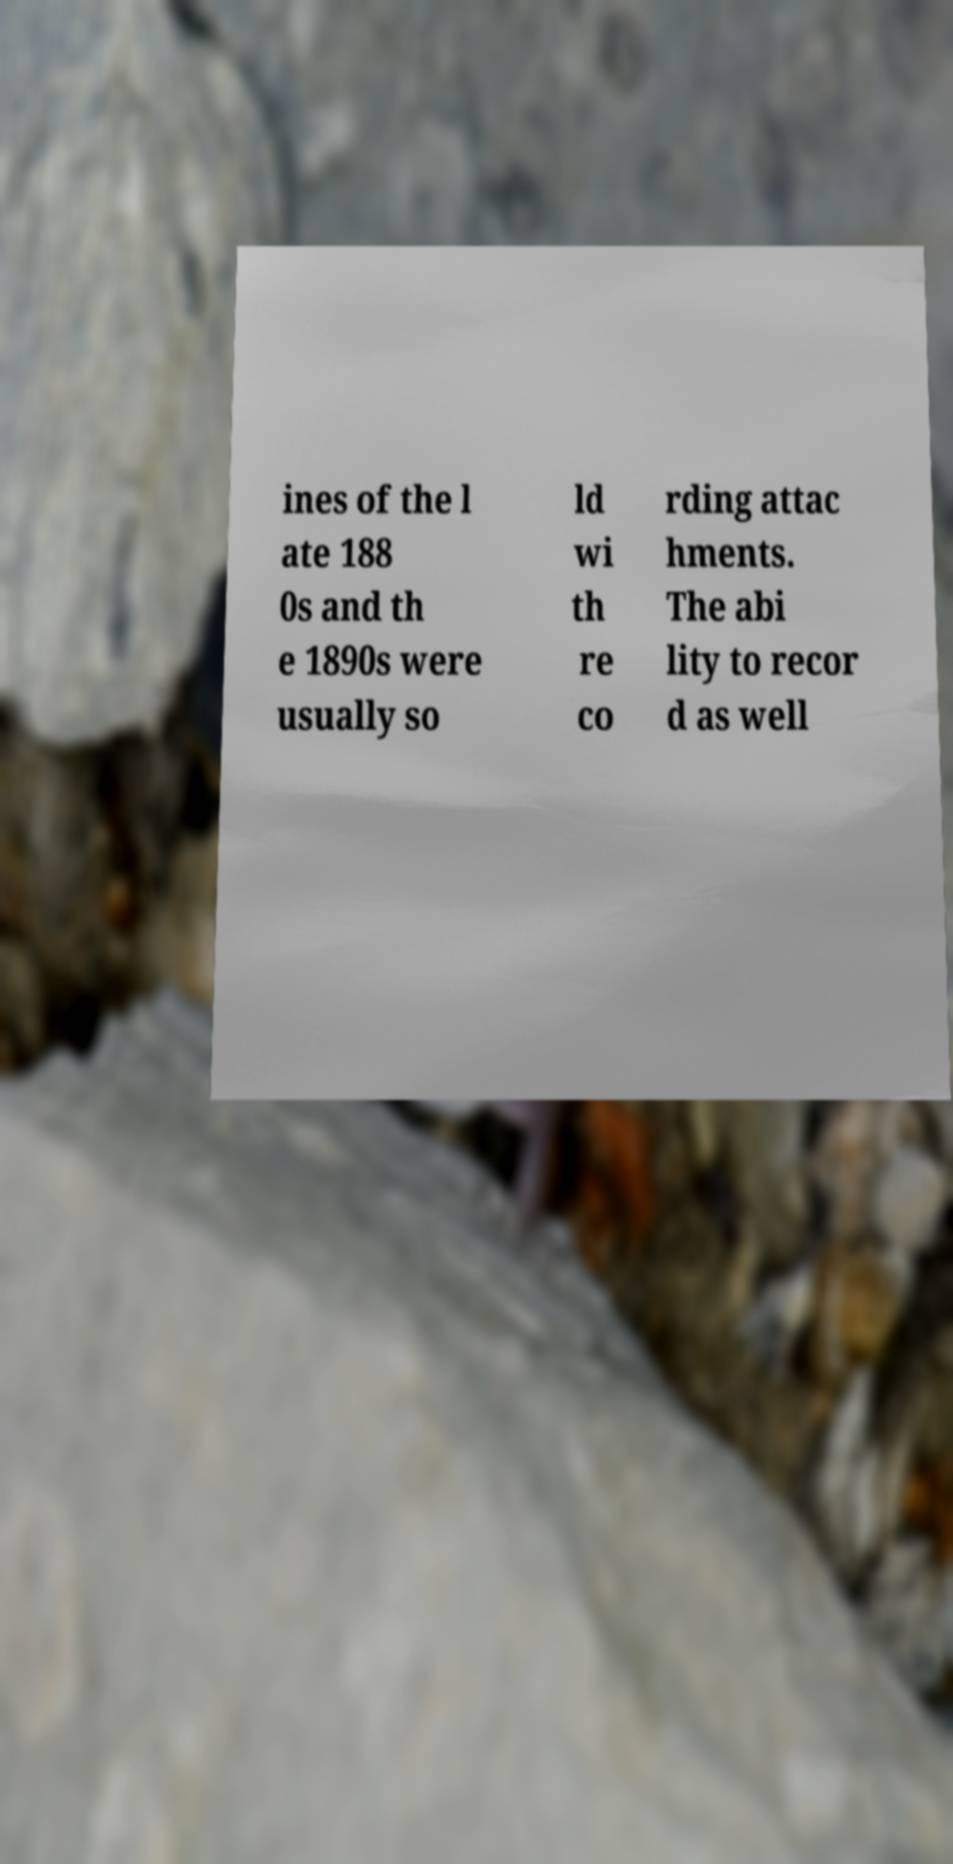Can you accurately transcribe the text from the provided image for me? ines of the l ate 188 0s and th e 1890s were usually so ld wi th re co rding attac hments. The abi lity to recor d as well 